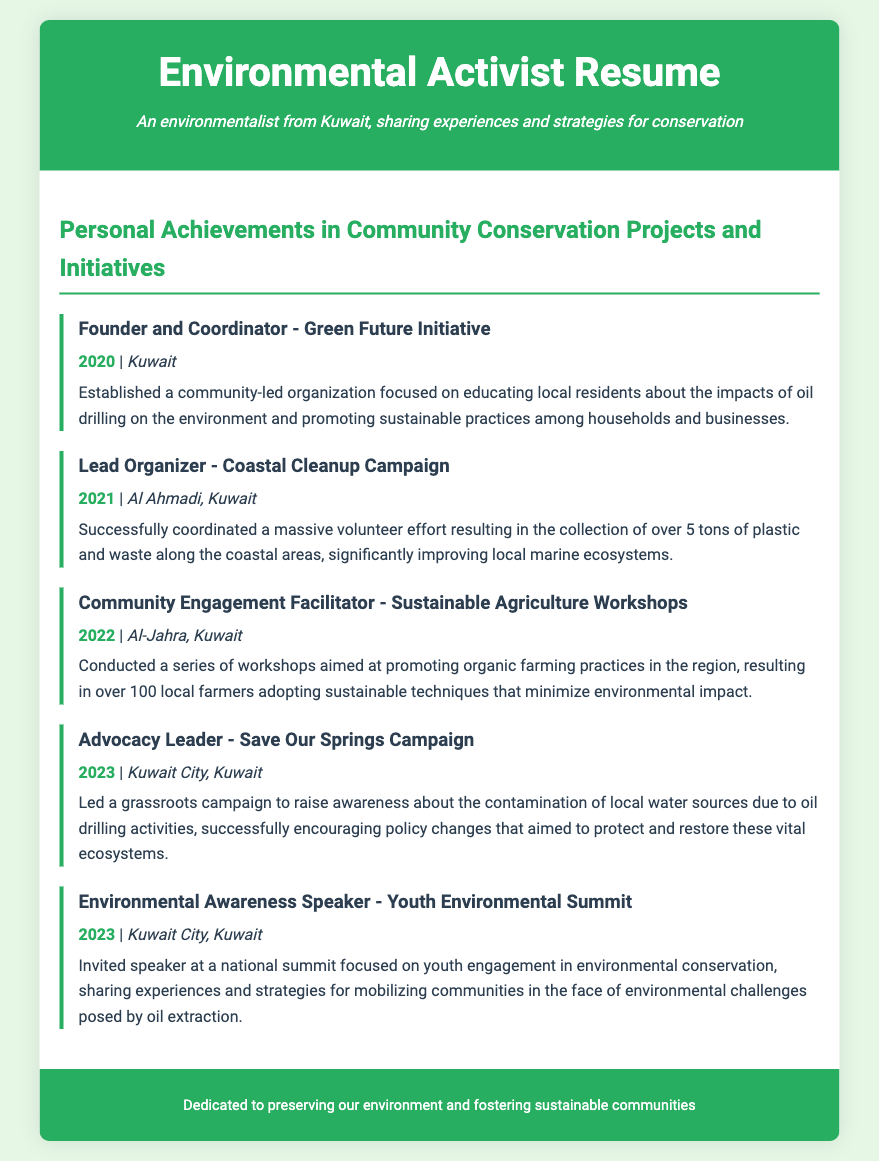What is the name of the initiative founded? The initiative focused on educating local residents about the impacts of oil drilling on the environment.
Answer: Green Future Initiative How many tons of waste were collected during the Coastal Cleanup Campaign? This achievement highlights the success of the volunteer effort in cleaning up the coastal areas.
Answer: 5 tons In which year were the Sustainable Agriculture Workshops conducted? The workshops aimed at promoting organic farming practices were held in this year.
Answer: 2022 What location hosted the Save Our Springs Campaign? The campaign raised awareness about the contamination of local water sources due to oil drilling.
Answer: Kuwait City, Kuwait Who led the grassroots campaign regarding local water sources? This person played a vital role in advocating for policy changes to protect ecosystems.
Answer: Advocacy Leader How many local farmers adopted sustainable techniques from the workshops? This number reflects the success and impact of the Sustainable Agriculture Workshops.
Answer: 100 What type of event was the Youth Environmental Summit? This event aimed at engaging young individuals in environmental conservation efforts.
Answer: National summit Which area experienced the Coastal Cleanup Campaign? The campaign targeted a specific region in Kuwait for environmental restoration.
Answer: Al Ahmadi, Kuwait What was the main focus of the Environmental Awareness Speaker role? This role involved sharing experiences related to mobilizing communities against oil extraction challenges.
Answer: Youth engagement in environmental conservation 